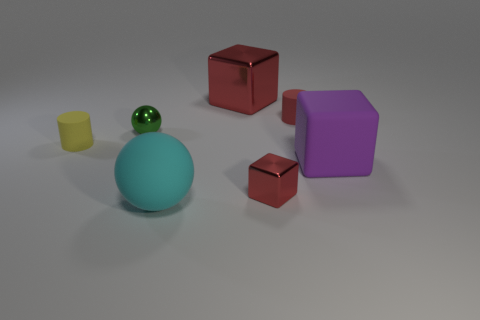Can you tell me the different colors present in this image? Certainly! The image showcases objects in red, yellow, green, blue, and purple. 